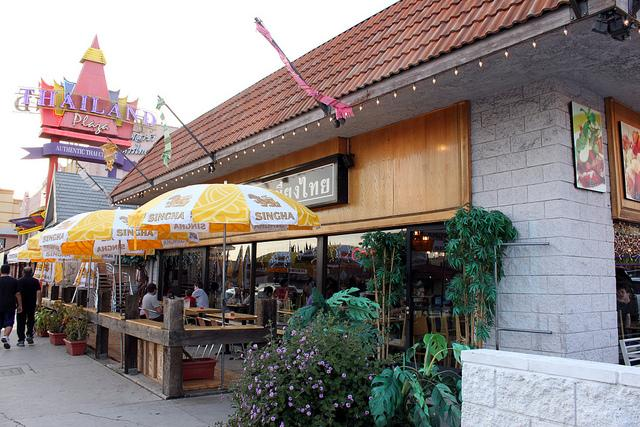What is the capital city of this country? Please explain your reasoning. bangkok. You can tell by the countries name on the sign as to where this is. 